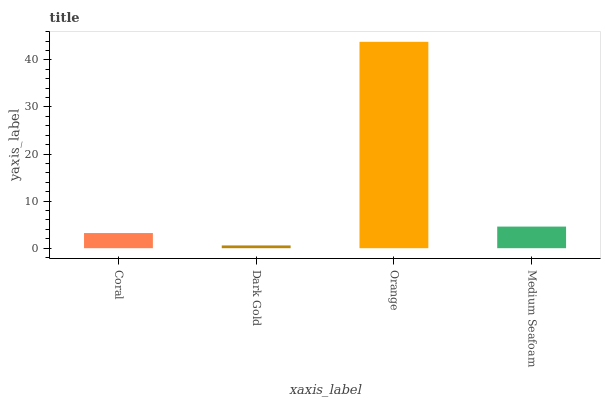Is Dark Gold the minimum?
Answer yes or no. Yes. Is Orange the maximum?
Answer yes or no. Yes. Is Orange the minimum?
Answer yes or no. No. Is Dark Gold the maximum?
Answer yes or no. No. Is Orange greater than Dark Gold?
Answer yes or no. Yes. Is Dark Gold less than Orange?
Answer yes or no. Yes. Is Dark Gold greater than Orange?
Answer yes or no. No. Is Orange less than Dark Gold?
Answer yes or no. No. Is Medium Seafoam the high median?
Answer yes or no. Yes. Is Coral the low median?
Answer yes or no. Yes. Is Coral the high median?
Answer yes or no. No. Is Dark Gold the low median?
Answer yes or no. No. 